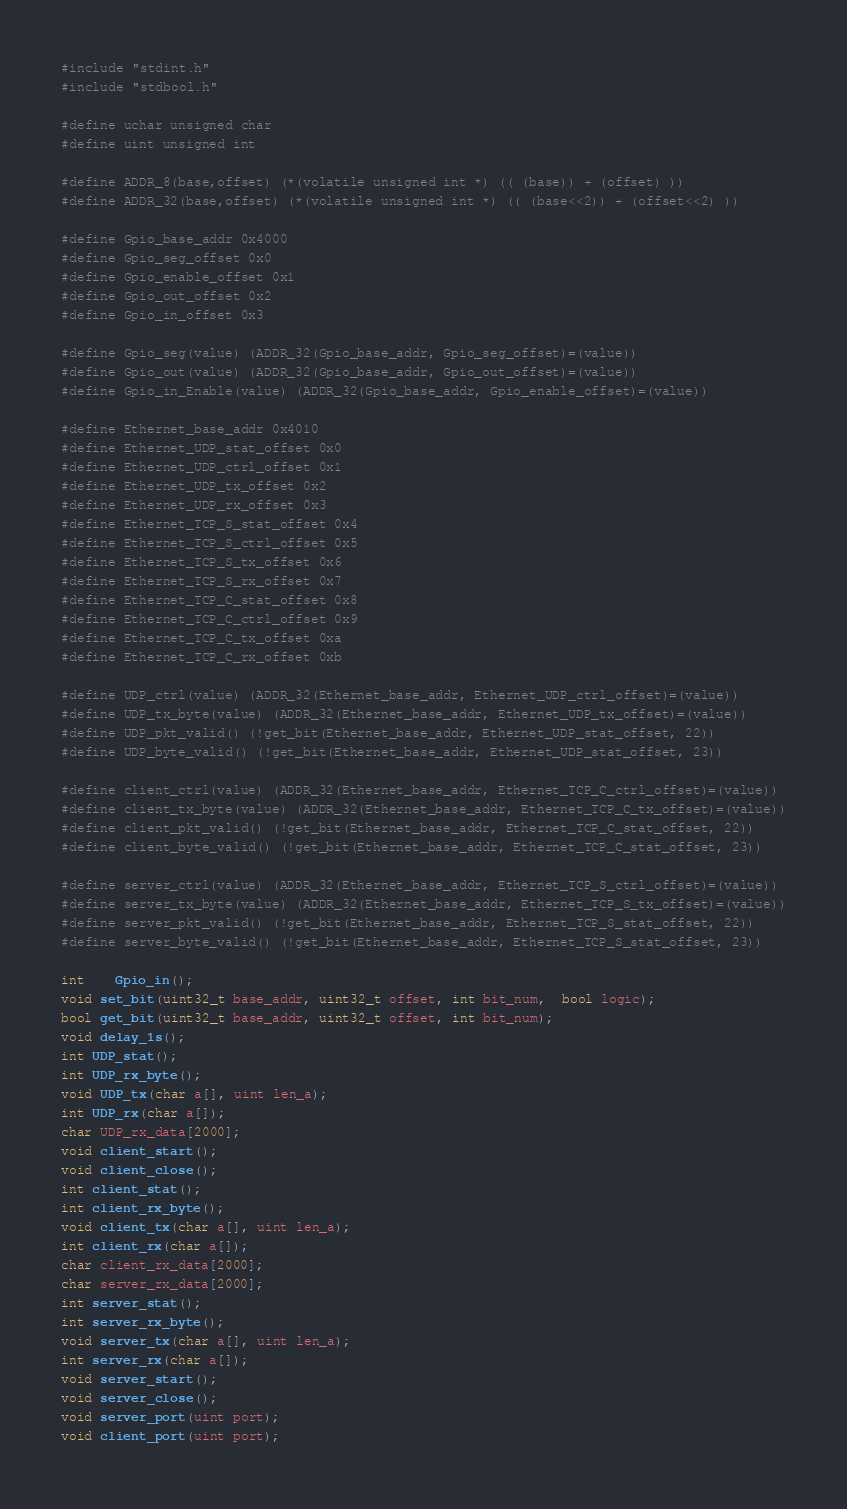<code> <loc_0><loc_0><loc_500><loc_500><_C_>#include "stdint.h"
#include "stdbool.h"

#define uchar unsigned char
#define uint unsigned int

#define ADDR_8(base,offset) (*(volatile unsigned int *) (( (base)) + (offset) ))
#define ADDR_32(base,offset) (*(volatile unsigned int *) (( (base<<2)) + (offset<<2) ))

#define Gpio_base_addr 0x4000
#define Gpio_seg_offset 0x0
#define Gpio_enable_offset 0x1
#define Gpio_out_offset 0x2
#define Gpio_in_offset 0x3

#define Gpio_seg(value) (ADDR_32(Gpio_base_addr, Gpio_seg_offset)=(value))
#define Gpio_out(value) (ADDR_32(Gpio_base_addr, Gpio_out_offset)=(value))
#define Gpio_in_Enable(value) (ADDR_32(Gpio_base_addr, Gpio_enable_offset)=(value))

#define Ethernet_base_addr 0x4010
#define Ethernet_UDP_stat_offset 0x0
#define Ethernet_UDP_ctrl_offset 0x1
#define Ethernet_UDP_tx_offset 0x2
#define Ethernet_UDP_rx_offset 0x3
#define Ethernet_TCP_S_stat_offset 0x4
#define Ethernet_TCP_S_ctrl_offset 0x5
#define Ethernet_TCP_S_tx_offset 0x6
#define Ethernet_TCP_S_rx_offset 0x7
#define Ethernet_TCP_C_stat_offset 0x8
#define Ethernet_TCP_C_ctrl_offset 0x9
#define Ethernet_TCP_C_tx_offset 0xa
#define Ethernet_TCP_C_rx_offset 0xb

#define UDP_ctrl(value) (ADDR_32(Ethernet_base_addr, Ethernet_UDP_ctrl_offset)=(value))
#define UDP_tx_byte(value) (ADDR_32(Ethernet_base_addr, Ethernet_UDP_tx_offset)=(value))
#define UDP_pkt_valid() (!get_bit(Ethernet_base_addr, Ethernet_UDP_stat_offset, 22))
#define UDP_byte_valid() (!get_bit(Ethernet_base_addr, Ethernet_UDP_stat_offset, 23))

#define client_ctrl(value) (ADDR_32(Ethernet_base_addr, Ethernet_TCP_C_ctrl_offset)=(value))
#define client_tx_byte(value) (ADDR_32(Ethernet_base_addr, Ethernet_TCP_C_tx_offset)=(value))
#define client_pkt_valid() (!get_bit(Ethernet_base_addr, Ethernet_TCP_C_stat_offset, 22))
#define client_byte_valid() (!get_bit(Ethernet_base_addr, Ethernet_TCP_C_stat_offset, 23))

#define server_ctrl(value) (ADDR_32(Ethernet_base_addr, Ethernet_TCP_S_ctrl_offset)=(value))
#define server_tx_byte(value) (ADDR_32(Ethernet_base_addr, Ethernet_TCP_S_tx_offset)=(value))
#define server_pkt_valid() (!get_bit(Ethernet_base_addr, Ethernet_TCP_S_stat_offset, 22))
#define server_byte_valid() (!get_bit(Ethernet_base_addr, Ethernet_TCP_S_stat_offset, 23))

int	Gpio_in();
void set_bit(uint32_t base_addr, uint32_t offset, int bit_num,  bool logic);
bool get_bit(uint32_t base_addr, uint32_t offset, int bit_num);
void delay_1s();
int UDP_stat();
int UDP_rx_byte();
void UDP_tx(char a[], uint len_a);
int UDP_rx(char a[]);
char UDP_rx_data[2000];
void client_start();
void client_close();
int client_stat();
int client_rx_byte();
void client_tx(char a[], uint len_a);
int client_rx(char a[]);
char client_rx_data[2000];
char server_rx_data[2000];
int server_stat();
int server_rx_byte();
void server_tx(char a[], uint len_a);
int server_rx(char a[]);
void server_start();
void server_close();
void server_port(uint port);
void client_port(uint port);
</code> 